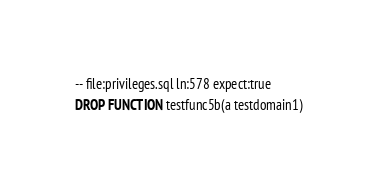<code> <loc_0><loc_0><loc_500><loc_500><_SQL_>-- file:privileges.sql ln:578 expect:true
DROP FUNCTION testfunc5b(a testdomain1)
</code> 